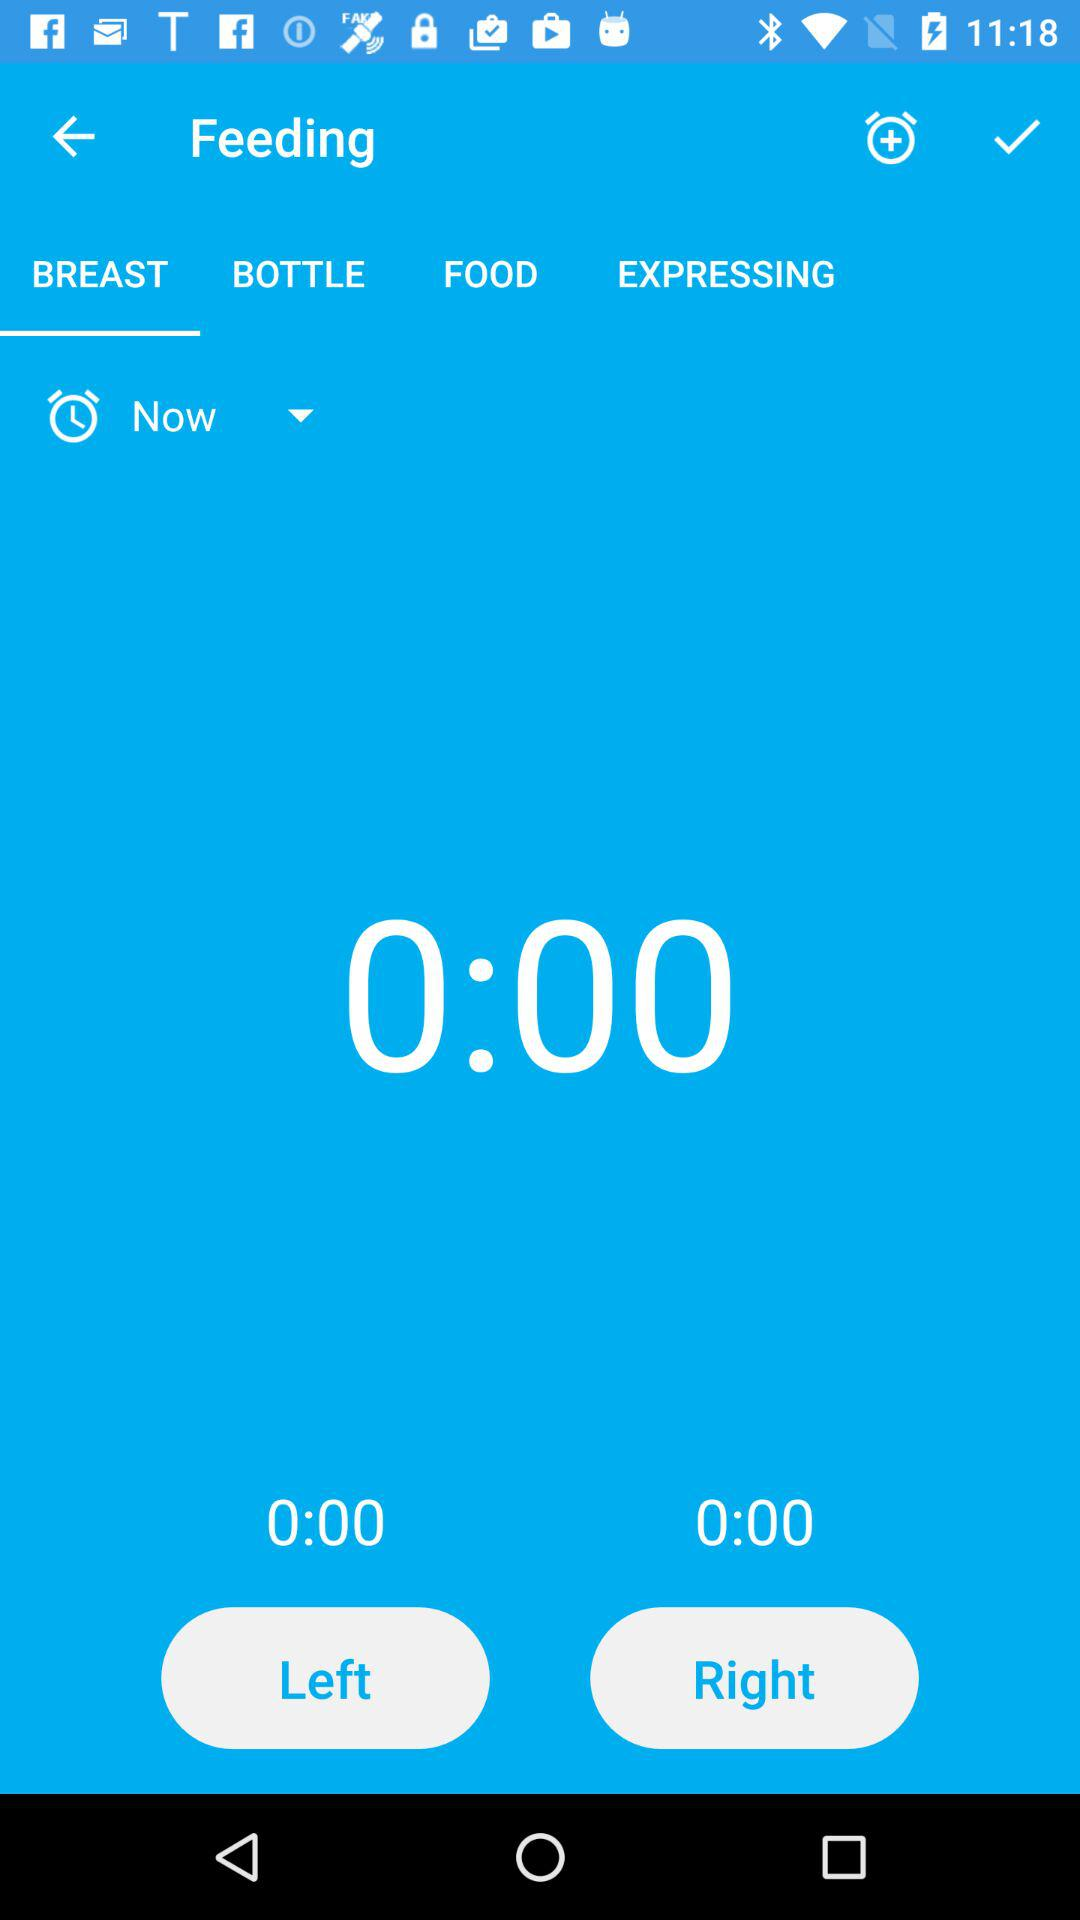On what tab of the application are we? The tab is "BREAST". 